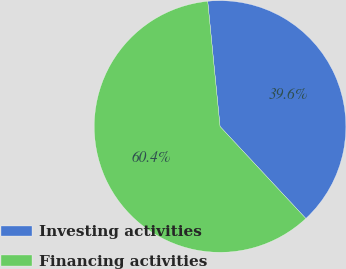<chart> <loc_0><loc_0><loc_500><loc_500><pie_chart><fcel>Investing activities<fcel>Financing activities<nl><fcel>39.62%<fcel>60.38%<nl></chart> 